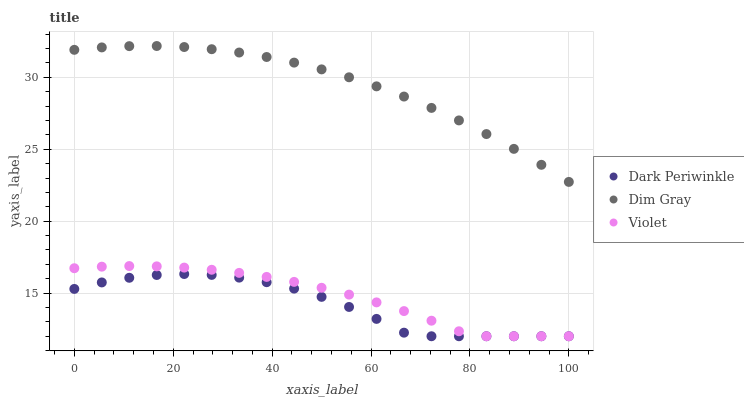Does Dark Periwinkle have the minimum area under the curve?
Answer yes or no. Yes. Does Dim Gray have the maximum area under the curve?
Answer yes or no. Yes. Does Violet have the minimum area under the curve?
Answer yes or no. No. Does Violet have the maximum area under the curve?
Answer yes or no. No. Is Dim Gray the smoothest?
Answer yes or no. Yes. Is Dark Periwinkle the roughest?
Answer yes or no. Yes. Is Violet the smoothest?
Answer yes or no. No. Is Violet the roughest?
Answer yes or no. No. Does Dark Periwinkle have the lowest value?
Answer yes or no. Yes. Does Dim Gray have the highest value?
Answer yes or no. Yes. Does Violet have the highest value?
Answer yes or no. No. Is Violet less than Dim Gray?
Answer yes or no. Yes. Is Dim Gray greater than Dark Periwinkle?
Answer yes or no. Yes. Does Dark Periwinkle intersect Violet?
Answer yes or no. Yes. Is Dark Periwinkle less than Violet?
Answer yes or no. No. Is Dark Periwinkle greater than Violet?
Answer yes or no. No. Does Violet intersect Dim Gray?
Answer yes or no. No. 